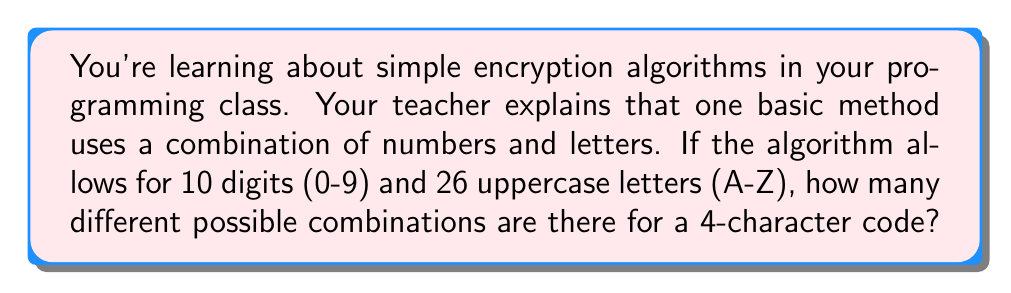Can you solve this math problem? Let's approach this step-by-step:

1) First, we need to understand what the question is asking:
   - We're creating a code that is 4 characters long
   - Each character can be either a digit (0-9) or an uppercase letter (A-Z)

2) Let's count our options:
   - There are 10 digits (0-9)
   - There are 26 uppercase letters (A-Z)
   - In total, we have 10 + 26 = 36 options for each character

3) Now, for each position in our 4-character code, we have 36 choices:
   - For the first character: 36 choices
   - For the second character: 36 choices
   - For the third character: 36 choices
   - For the fourth character: 36 choices

4) In mathematics, when we have a series of independent choices, we multiply the number of options for each choice:

   $$ \text{Total combinations} = 36 \times 36 \times 36 \times 36 $$

5) This can be written as an exponent:

   $$ \text{Total combinations} = 36^4 $$

6) Let's calculate this:
   $$ 36^4 = 36 \times 36 \times 36 \times 36 = 1,679,616 $$

Therefore, there are 1,679,616 different possible combinations for a 4-character code using this simple encryption algorithm.
Answer: $1,679,616$ 